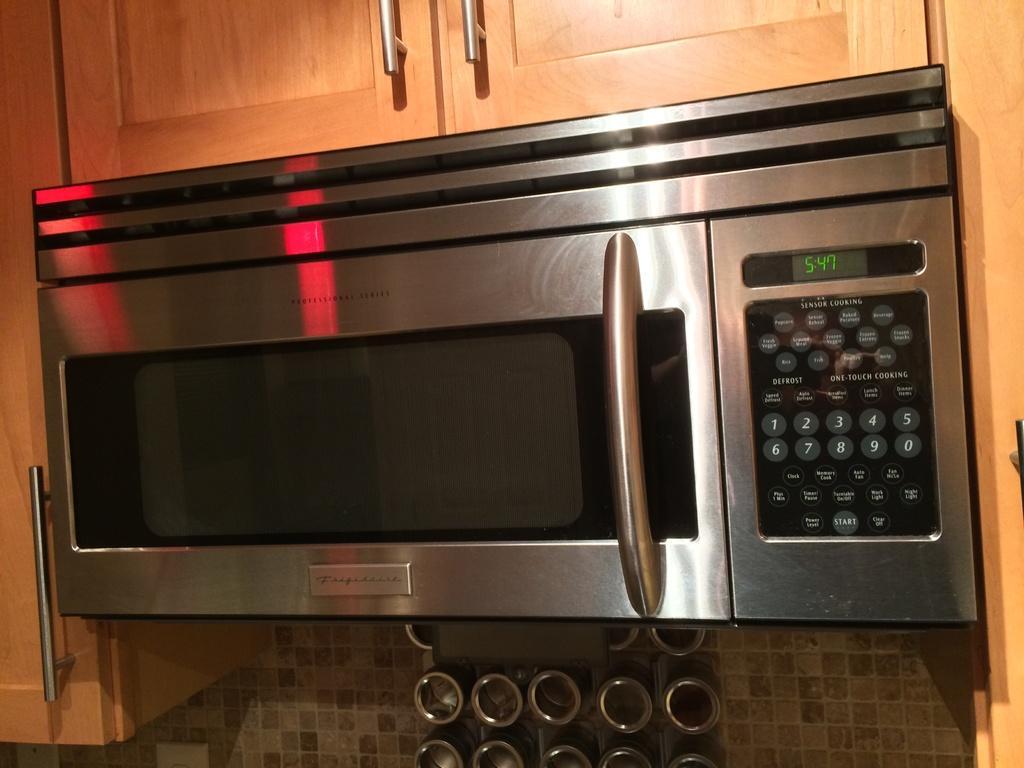Can you describe this image briefly? In this picture I can see there is a oven and it has a door and there are few buttons on to right with a display screen and there are shelves around the micro oven. 